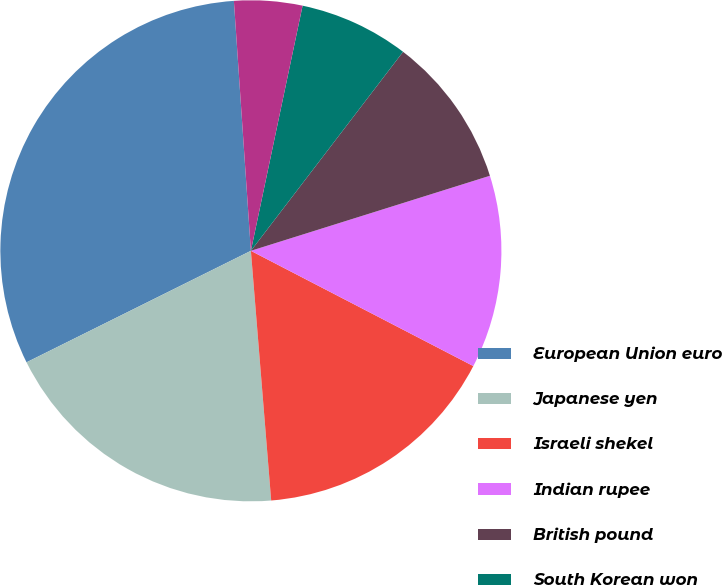<chart> <loc_0><loc_0><loc_500><loc_500><pie_chart><fcel>European Union euro<fcel>Japanese yen<fcel>Israeli shekel<fcel>Indian rupee<fcel>British pound<fcel>South Korean won<fcel>Chinese renminbi<nl><fcel>31.26%<fcel>18.95%<fcel>16.1%<fcel>12.45%<fcel>9.77%<fcel>7.08%<fcel>4.39%<nl></chart> 